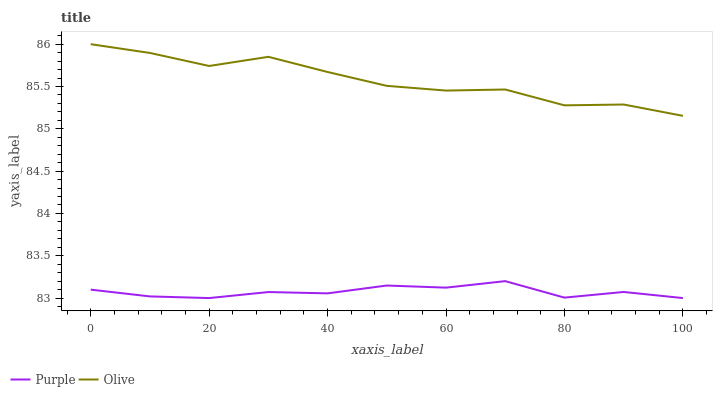Does Purple have the minimum area under the curve?
Answer yes or no. Yes. Does Olive have the maximum area under the curve?
Answer yes or no. Yes. Does Olive have the minimum area under the curve?
Answer yes or no. No. Is Purple the smoothest?
Answer yes or no. Yes. Is Olive the roughest?
Answer yes or no. Yes. Is Olive the smoothest?
Answer yes or no. No. Does Purple have the lowest value?
Answer yes or no. Yes. Does Olive have the lowest value?
Answer yes or no. No. Does Olive have the highest value?
Answer yes or no. Yes. Is Purple less than Olive?
Answer yes or no. Yes. Is Olive greater than Purple?
Answer yes or no. Yes. Does Purple intersect Olive?
Answer yes or no. No. 